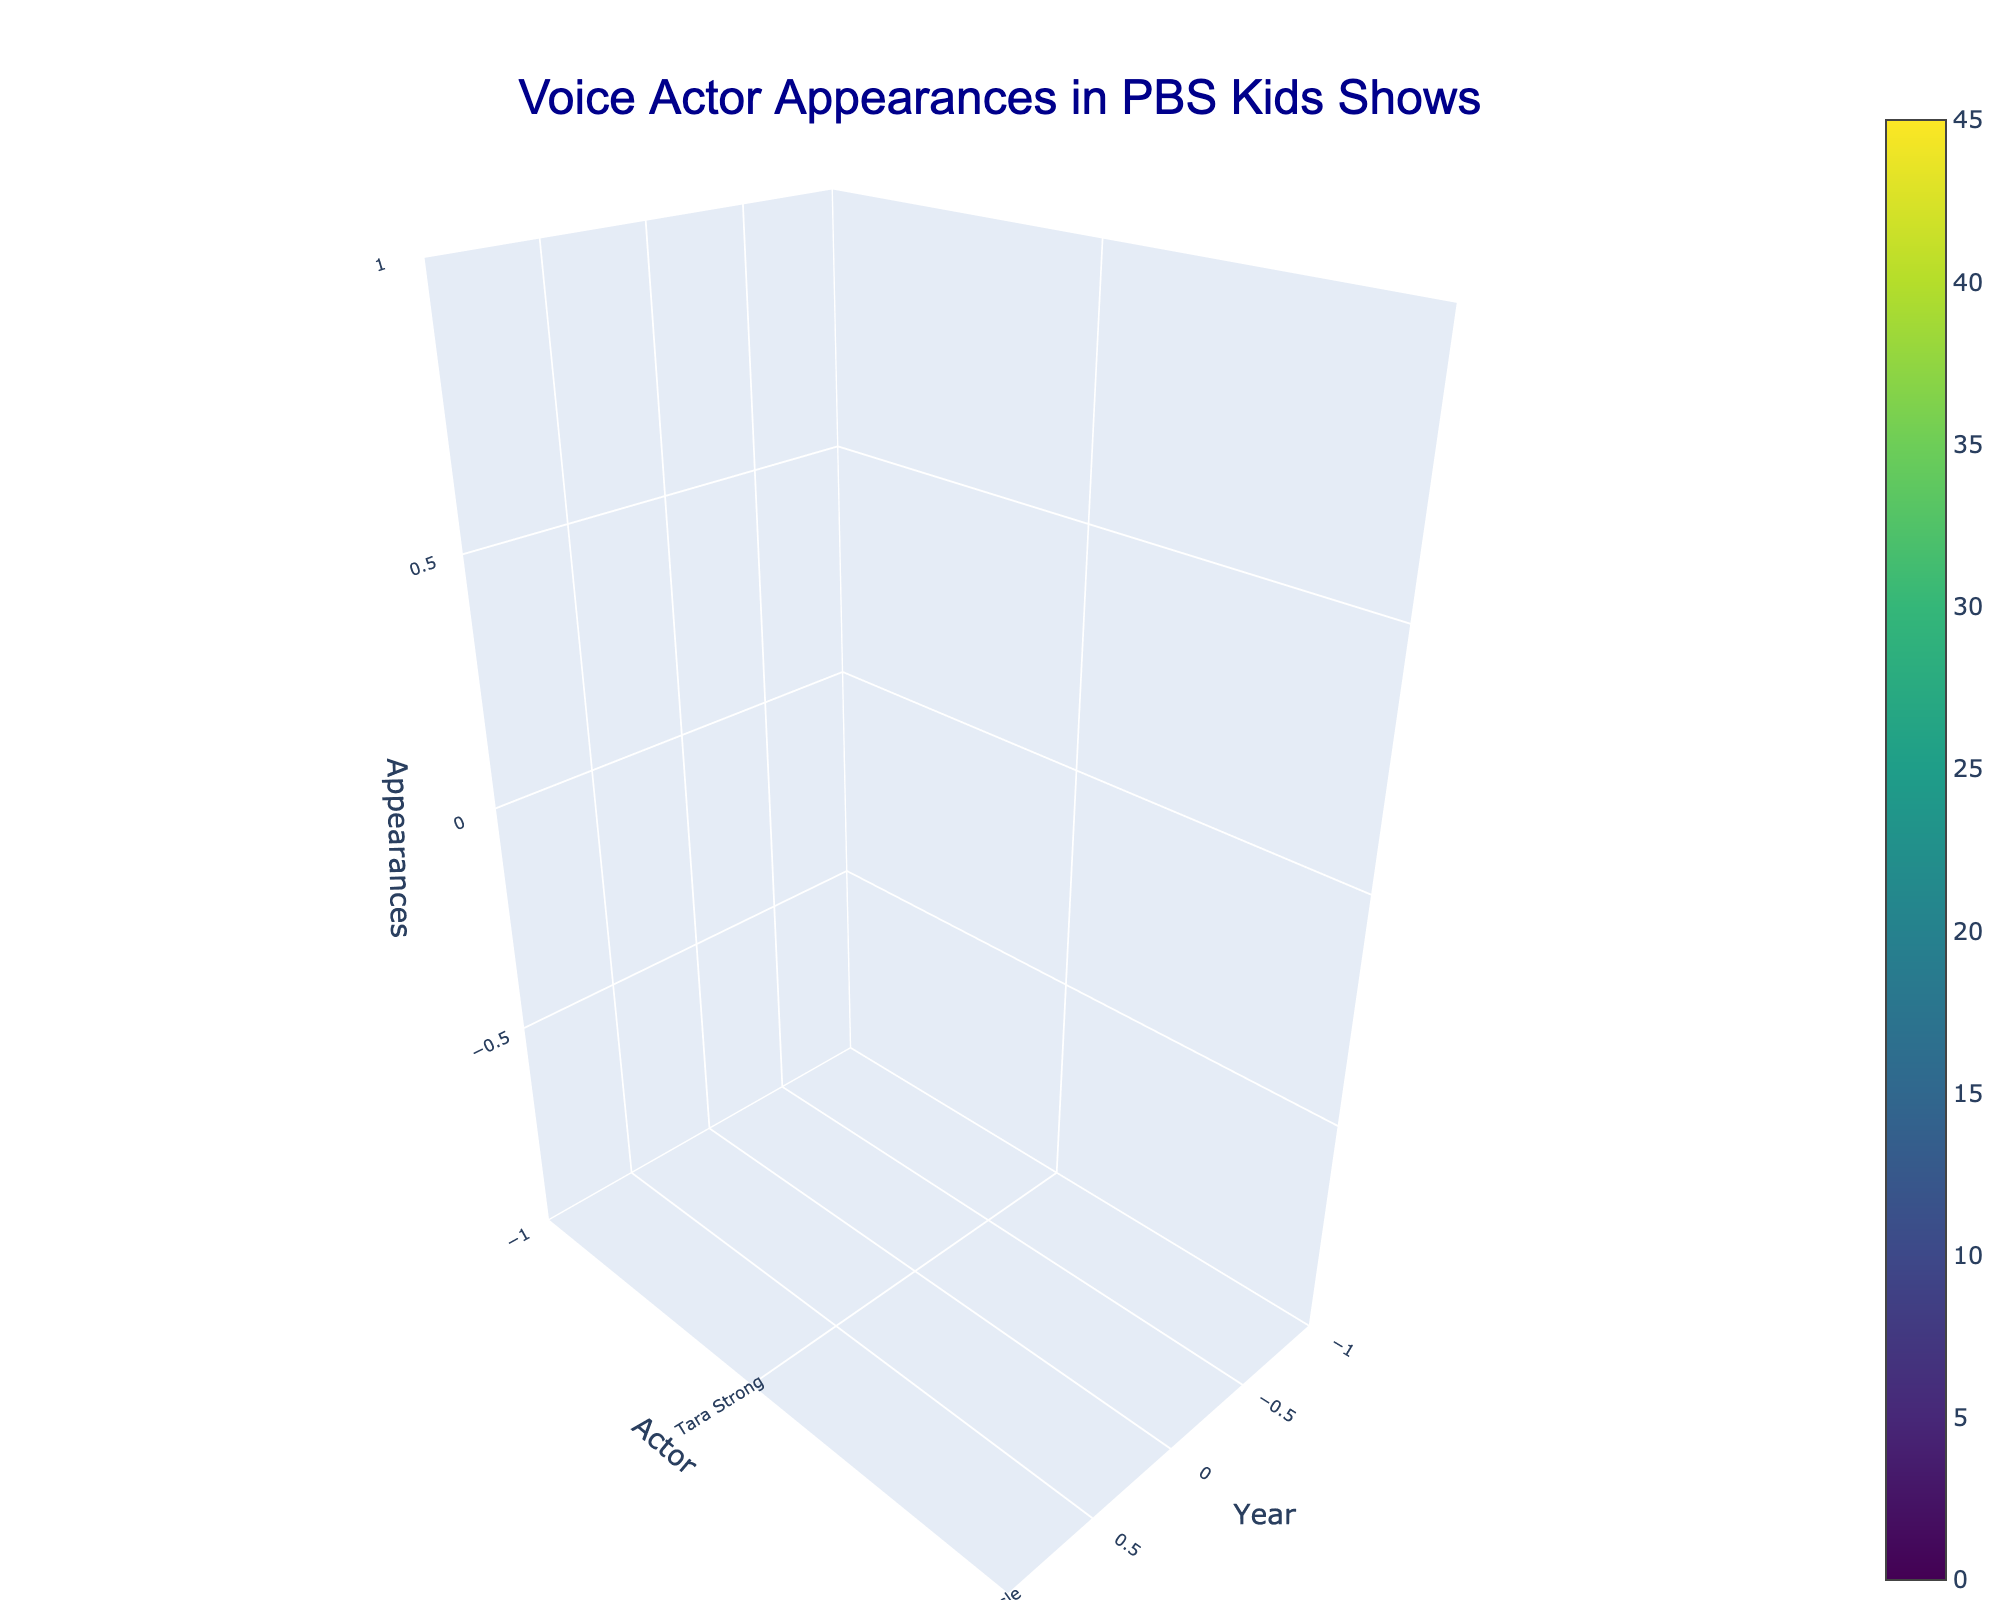What is the title of the 3D volume plot? The title is usually found at the top of the plot. Here, it states the purpose or subject of the visualization directly.
Answer: Voice Actor Appearances in PBS Kids Shows Which actor had the most appearances in the year 2020? To answer this, we locate the data points for the year 2020 and check which actor had the highest value on the z-axis (appearances).
Answer: Joanne Vannicola How many appearances did Jim Cummings make in 2010? Look for the intersection of the year 2010 and actor Jim Cummings, then read off the value on the z-axis.
Answer: 40 Compare the total appearances of the actors in 2005 and 2015. Which year had more total appearances? Add up all the appearances of actors in each year: For 2005, Grey DeLisle (30) + Martin Short (20) = 50. For 2015, Cree Summer (35) + Alyson Court (28) = 63. Then compare the sums.
Answer: 2015 What is the average number of appearances for all the actors in the year 2020? Sum all the appearances for 2020 and divide by the number of actors: (Joanne Vannicola 45 + Dee Bradley Baker 38) / 2 = 41.5.
Answer: 41.5 Of the actors listed, who has contributed to the greatest number of shows over the recorded years, and what is the number of shows? Identify the actor with the most unique show entries across all years. Tara Strong appears in two shows in 2000, Grey DeLisle in two in 2005, Jim Cummings in two in 2010, etc. The calculation must be for all years.
Answer: Grey DeLisle (4 shows) Which actor had fewer appearances in 2000, Tara Strong or Whoopi Goldberg? Compare the z-values (appearances) for Tara Strong and Whoopi Goldberg in the year 2000. Tara Strong had 25, and Whoopi Goldberg had 22.
Answer: Whoopi Goldberg In 2015, who had more appearances: Cree Summer or Alyson Court? Compare the z-values (appearances) for these two actors in the year 2015. Cree Summer had 35, and Alyson Court had 28.
Answer: Cree Summer How does the number of appearances by Tara Strong in 2000 compare to Jim Cummings in 2010? Compare the z-values (appearances) for these two actors in their respective years. Tara Strong had 25, and Jim Cummings had 40. Jim Cummings had more.
Answer: Jim Cummings Which actor had consistent appearances over two recorded years: 2000 and 2005, or 2010 and 2015? Check whether any actor appears in the list with entries in both pairs of years. There is no actor consistently listed in both pairs mentioned, so consider the only valid pairages.
Answer: None 